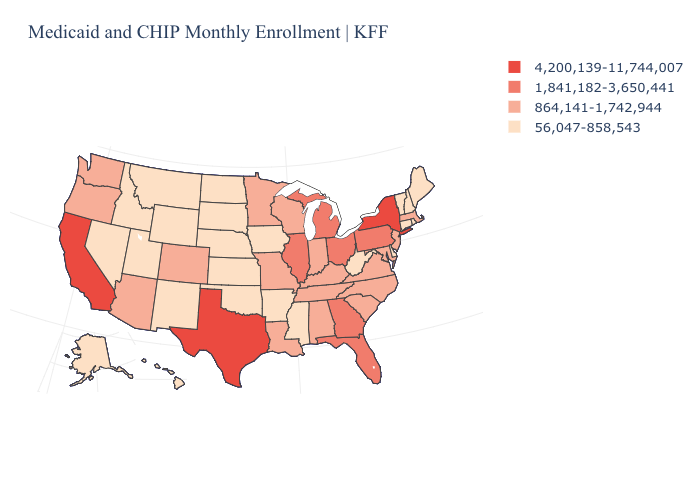What is the lowest value in states that border North Dakota?
Quick response, please. 56,047-858,543. What is the lowest value in the USA?
Keep it brief. 56,047-858,543. What is the value of California?
Keep it brief. 4,200,139-11,744,007. Among the states that border Texas , which have the highest value?
Short answer required. Louisiana. What is the highest value in the MidWest ?
Give a very brief answer. 1,841,182-3,650,441. What is the value of Virginia?
Keep it brief. 864,141-1,742,944. Among the states that border Georgia , does South Carolina have the highest value?
Write a very short answer. No. Name the states that have a value in the range 1,841,182-3,650,441?
Keep it brief. Florida, Georgia, Illinois, Michigan, Ohio, Pennsylvania. Which states have the lowest value in the USA?
Write a very short answer. Alaska, Arkansas, Connecticut, Delaware, Hawaii, Idaho, Iowa, Kansas, Maine, Mississippi, Montana, Nebraska, Nevada, New Hampshire, New Mexico, North Dakota, Oklahoma, Rhode Island, South Dakota, Utah, Vermont, West Virginia, Wyoming. What is the highest value in states that border West Virginia?
Answer briefly. 1,841,182-3,650,441. Which states have the lowest value in the USA?
Write a very short answer. Alaska, Arkansas, Connecticut, Delaware, Hawaii, Idaho, Iowa, Kansas, Maine, Mississippi, Montana, Nebraska, Nevada, New Hampshire, New Mexico, North Dakota, Oklahoma, Rhode Island, South Dakota, Utah, Vermont, West Virginia, Wyoming. Does Georgia have the lowest value in the USA?
Write a very short answer. No. Name the states that have a value in the range 56,047-858,543?
Keep it brief. Alaska, Arkansas, Connecticut, Delaware, Hawaii, Idaho, Iowa, Kansas, Maine, Mississippi, Montana, Nebraska, Nevada, New Hampshire, New Mexico, North Dakota, Oklahoma, Rhode Island, South Dakota, Utah, Vermont, West Virginia, Wyoming. Which states hav the highest value in the MidWest?
Keep it brief. Illinois, Michigan, Ohio. Among the states that border New Jersey , which have the lowest value?
Be succinct. Delaware. 